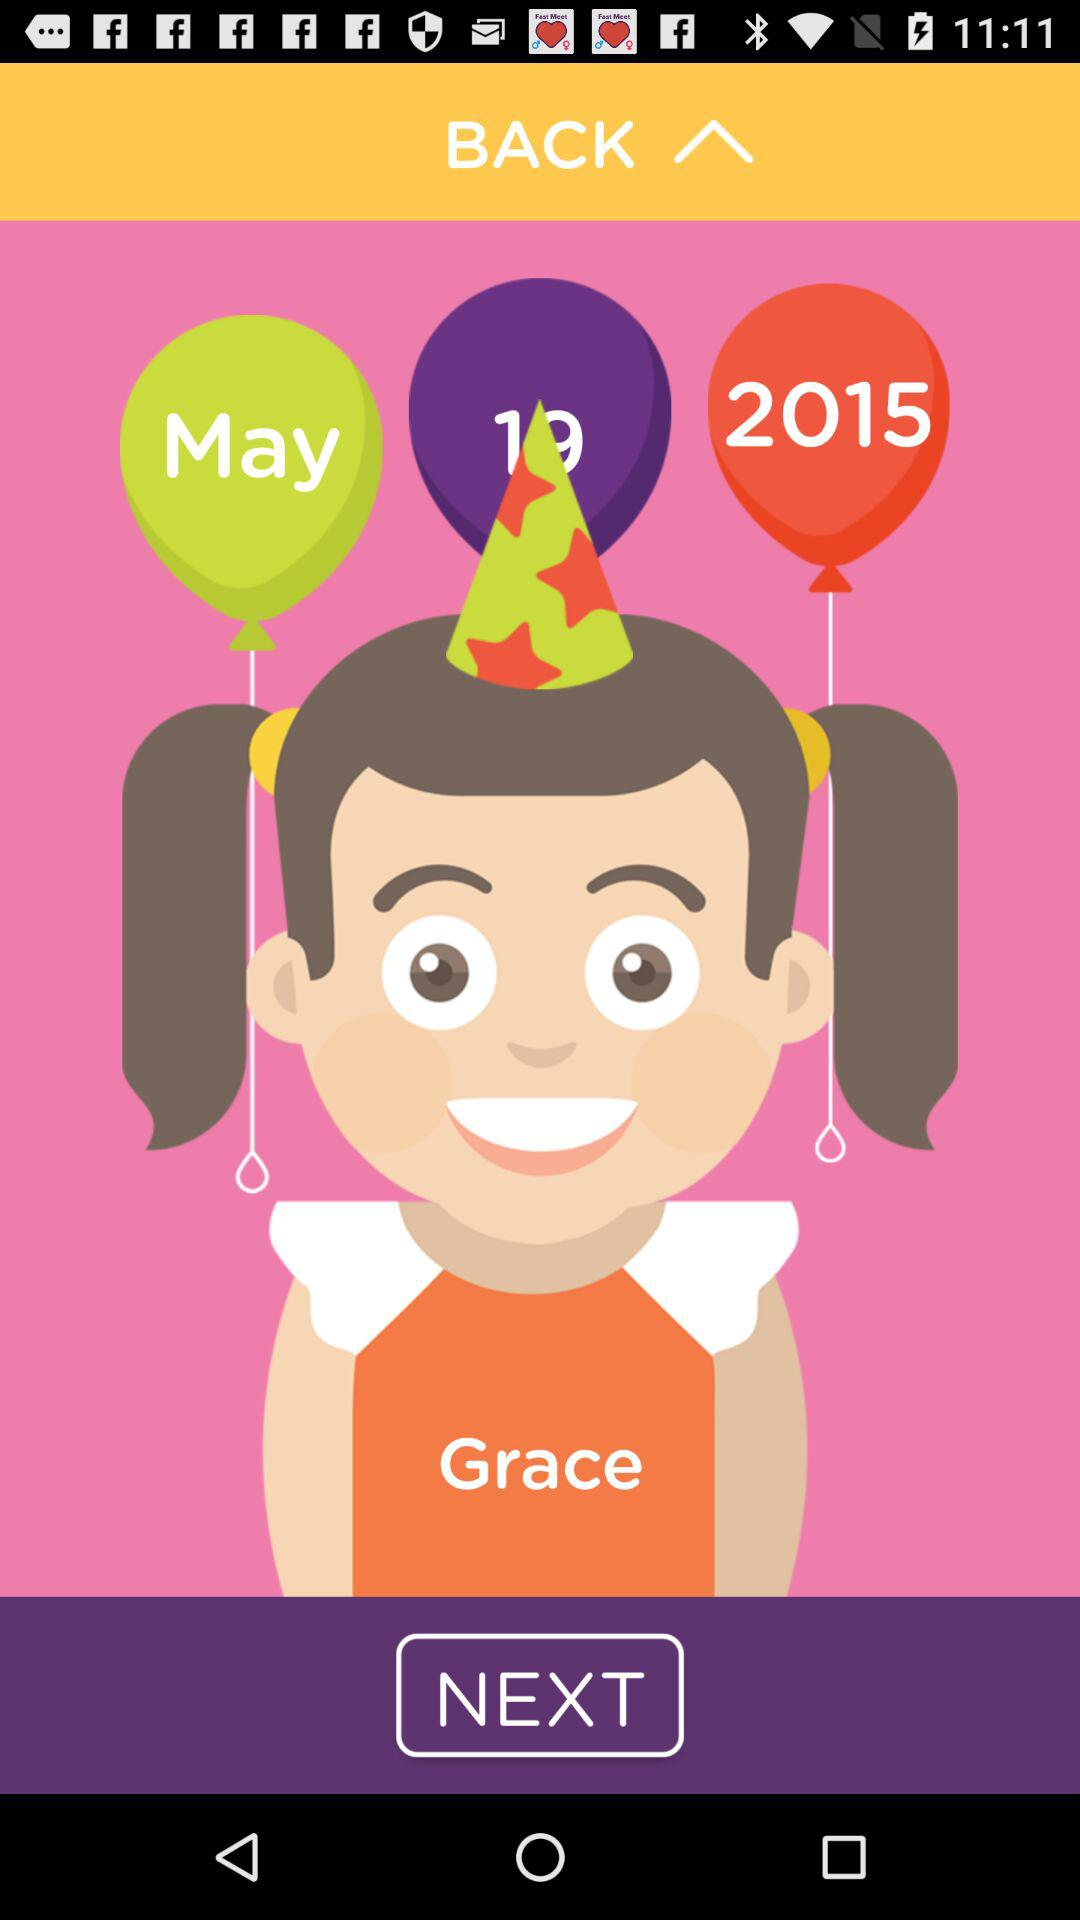What is the user name? The user name is Grace. 